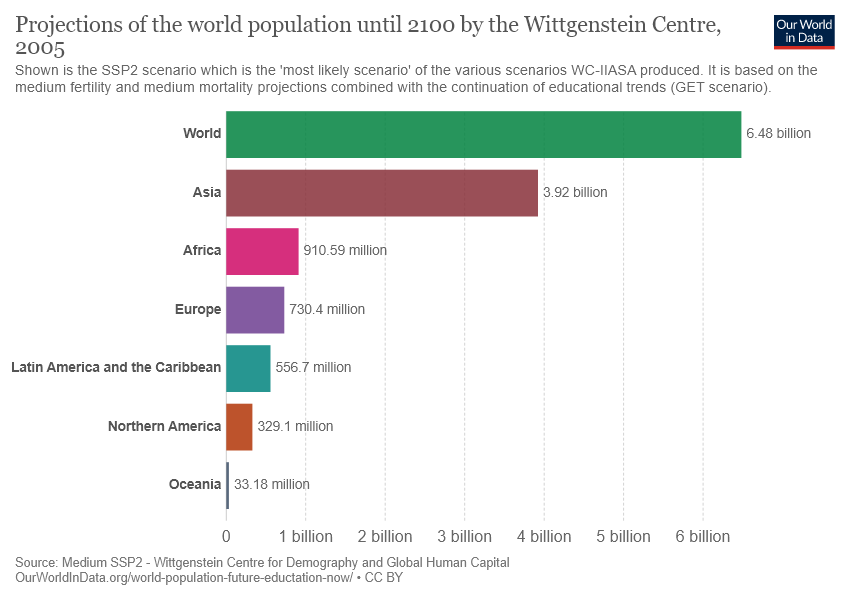Draw attention to some important aspects in this diagram. The value of the largest bar is 6.48. The difference between the smallest two bars in a group is not half the value of the third smallest bar. 